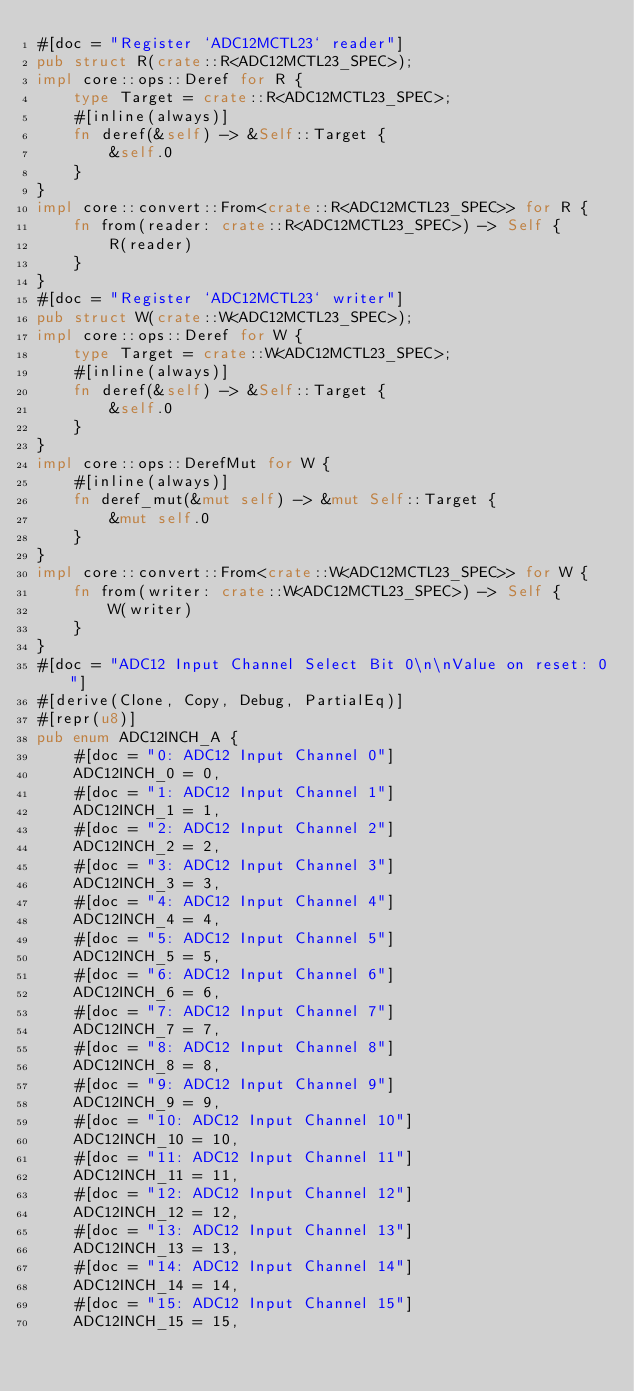Convert code to text. <code><loc_0><loc_0><loc_500><loc_500><_Rust_>#[doc = "Register `ADC12MCTL23` reader"]
pub struct R(crate::R<ADC12MCTL23_SPEC>);
impl core::ops::Deref for R {
    type Target = crate::R<ADC12MCTL23_SPEC>;
    #[inline(always)]
    fn deref(&self) -> &Self::Target {
        &self.0
    }
}
impl core::convert::From<crate::R<ADC12MCTL23_SPEC>> for R {
    fn from(reader: crate::R<ADC12MCTL23_SPEC>) -> Self {
        R(reader)
    }
}
#[doc = "Register `ADC12MCTL23` writer"]
pub struct W(crate::W<ADC12MCTL23_SPEC>);
impl core::ops::Deref for W {
    type Target = crate::W<ADC12MCTL23_SPEC>;
    #[inline(always)]
    fn deref(&self) -> &Self::Target {
        &self.0
    }
}
impl core::ops::DerefMut for W {
    #[inline(always)]
    fn deref_mut(&mut self) -> &mut Self::Target {
        &mut self.0
    }
}
impl core::convert::From<crate::W<ADC12MCTL23_SPEC>> for W {
    fn from(writer: crate::W<ADC12MCTL23_SPEC>) -> Self {
        W(writer)
    }
}
#[doc = "ADC12 Input Channel Select Bit 0\n\nValue on reset: 0"]
#[derive(Clone, Copy, Debug, PartialEq)]
#[repr(u8)]
pub enum ADC12INCH_A {
    #[doc = "0: ADC12 Input Channel 0"]
    ADC12INCH_0 = 0,
    #[doc = "1: ADC12 Input Channel 1"]
    ADC12INCH_1 = 1,
    #[doc = "2: ADC12 Input Channel 2"]
    ADC12INCH_2 = 2,
    #[doc = "3: ADC12 Input Channel 3"]
    ADC12INCH_3 = 3,
    #[doc = "4: ADC12 Input Channel 4"]
    ADC12INCH_4 = 4,
    #[doc = "5: ADC12 Input Channel 5"]
    ADC12INCH_5 = 5,
    #[doc = "6: ADC12 Input Channel 6"]
    ADC12INCH_6 = 6,
    #[doc = "7: ADC12 Input Channel 7"]
    ADC12INCH_7 = 7,
    #[doc = "8: ADC12 Input Channel 8"]
    ADC12INCH_8 = 8,
    #[doc = "9: ADC12 Input Channel 9"]
    ADC12INCH_9 = 9,
    #[doc = "10: ADC12 Input Channel 10"]
    ADC12INCH_10 = 10,
    #[doc = "11: ADC12 Input Channel 11"]
    ADC12INCH_11 = 11,
    #[doc = "12: ADC12 Input Channel 12"]
    ADC12INCH_12 = 12,
    #[doc = "13: ADC12 Input Channel 13"]
    ADC12INCH_13 = 13,
    #[doc = "14: ADC12 Input Channel 14"]
    ADC12INCH_14 = 14,
    #[doc = "15: ADC12 Input Channel 15"]
    ADC12INCH_15 = 15,</code> 